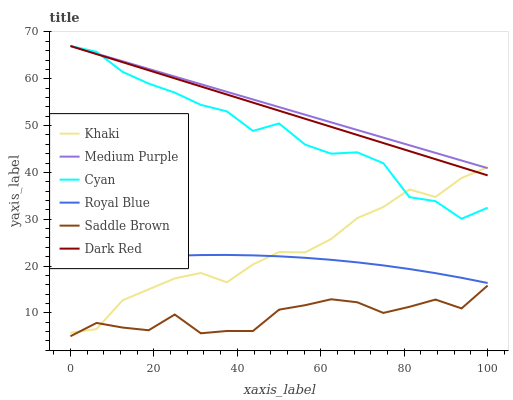Does Saddle Brown have the minimum area under the curve?
Answer yes or no. Yes. Does Medium Purple have the maximum area under the curve?
Answer yes or no. Yes. Does Dark Red have the minimum area under the curve?
Answer yes or no. No. Does Dark Red have the maximum area under the curve?
Answer yes or no. No. Is Medium Purple the smoothest?
Answer yes or no. Yes. Is Cyan the roughest?
Answer yes or no. Yes. Is Dark Red the smoothest?
Answer yes or no. No. Is Dark Red the roughest?
Answer yes or no. No. Does Saddle Brown have the lowest value?
Answer yes or no. Yes. Does Dark Red have the lowest value?
Answer yes or no. No. Does Cyan have the highest value?
Answer yes or no. Yes. Does Royal Blue have the highest value?
Answer yes or no. No. Is Royal Blue less than Cyan?
Answer yes or no. Yes. Is Medium Purple greater than Saddle Brown?
Answer yes or no. Yes. Does Khaki intersect Dark Red?
Answer yes or no. Yes. Is Khaki less than Dark Red?
Answer yes or no. No. Is Khaki greater than Dark Red?
Answer yes or no. No. Does Royal Blue intersect Cyan?
Answer yes or no. No. 